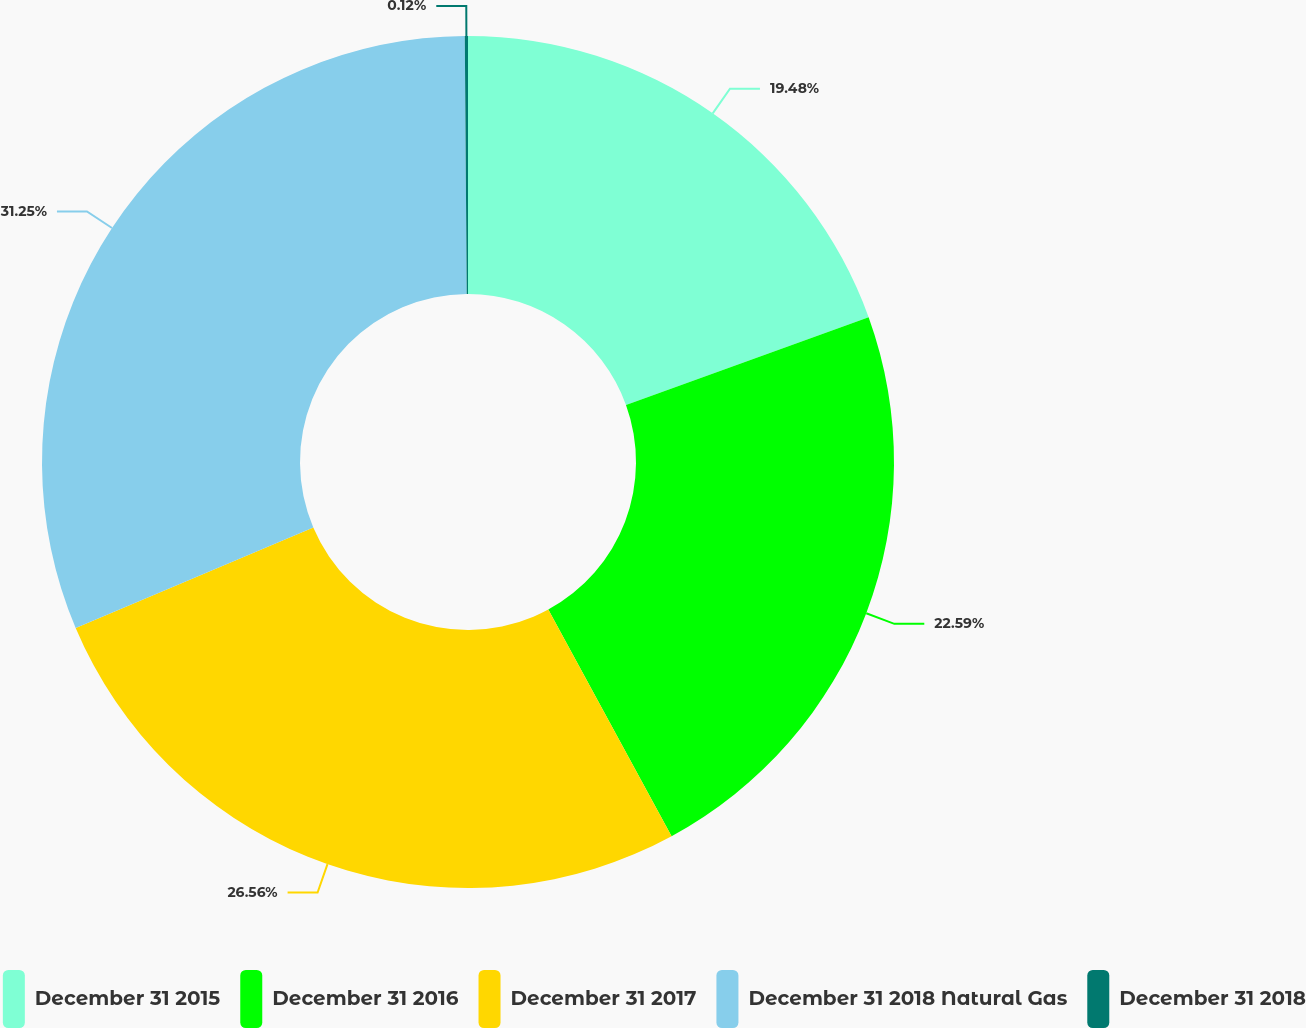<chart> <loc_0><loc_0><loc_500><loc_500><pie_chart><fcel>December 31 2015<fcel>December 31 2016<fcel>December 31 2017<fcel>December 31 2018 Natural Gas<fcel>December 31 2018<nl><fcel>19.48%<fcel>22.59%<fcel>26.56%<fcel>31.25%<fcel>0.12%<nl></chart> 